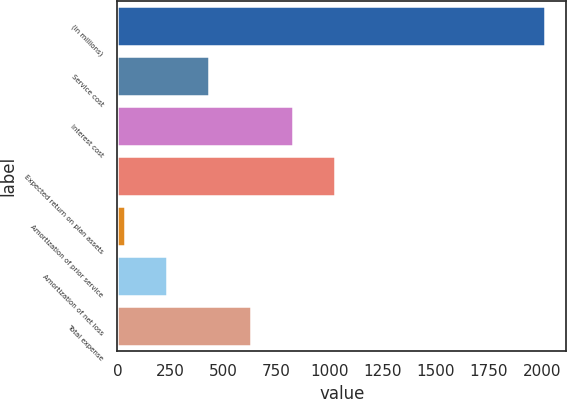<chart> <loc_0><loc_0><loc_500><loc_500><bar_chart><fcel>(in millions)<fcel>Service cost<fcel>Interest cost<fcel>Expected return on plan assets<fcel>Amortization of prior service<fcel>Amortization of net loss<fcel>Total expense<nl><fcel>2012<fcel>430.4<fcel>825.8<fcel>1023.5<fcel>35<fcel>232.7<fcel>628.1<nl></chart> 